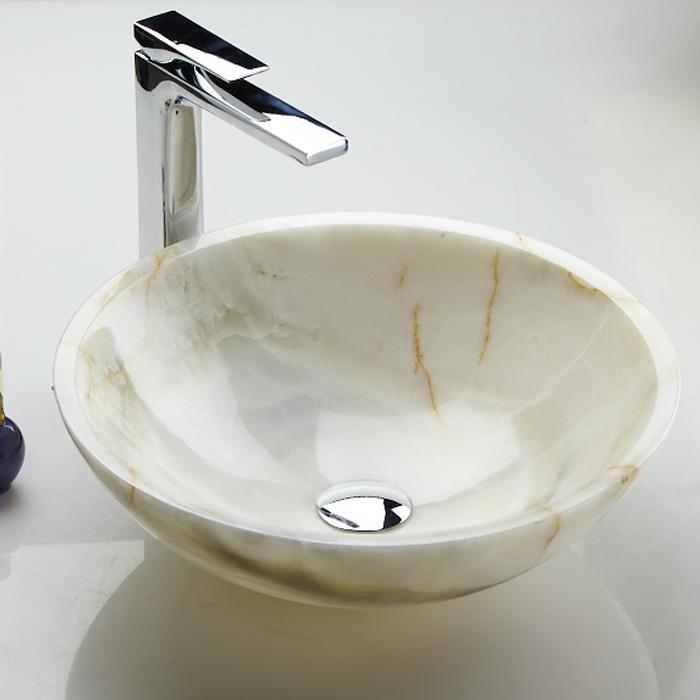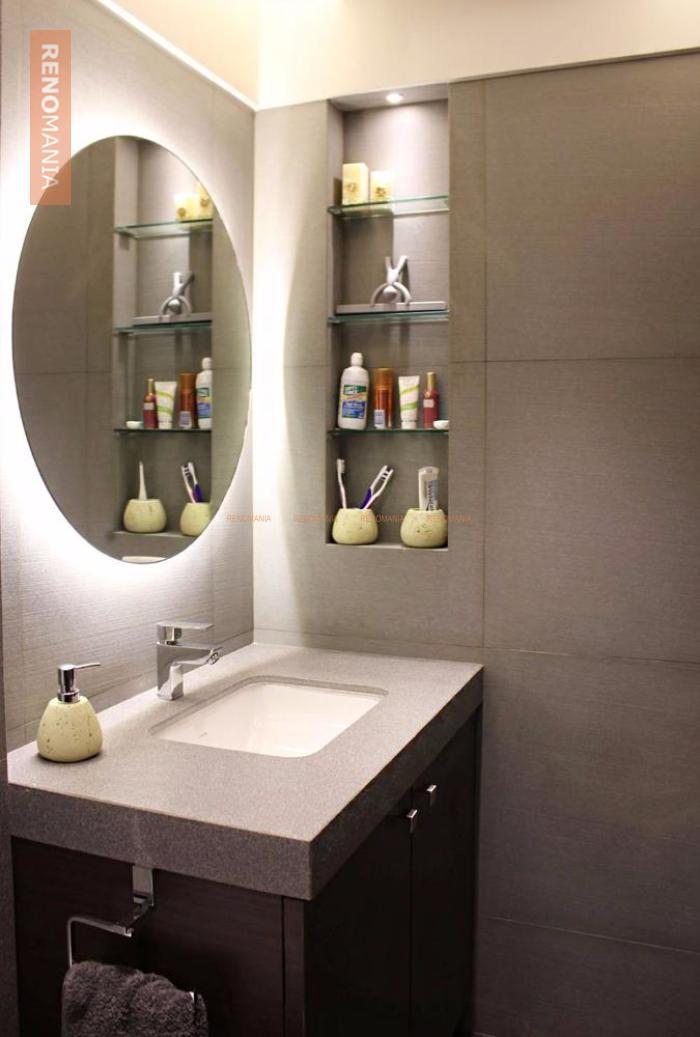The first image is the image on the left, the second image is the image on the right. Considering the images on both sides, is "There is a mirror behind one of the sinks." valid? Answer yes or no. Yes. 